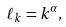<formula> <loc_0><loc_0><loc_500><loc_500>\ell _ { k } = k ^ { \alpha } ,</formula> 